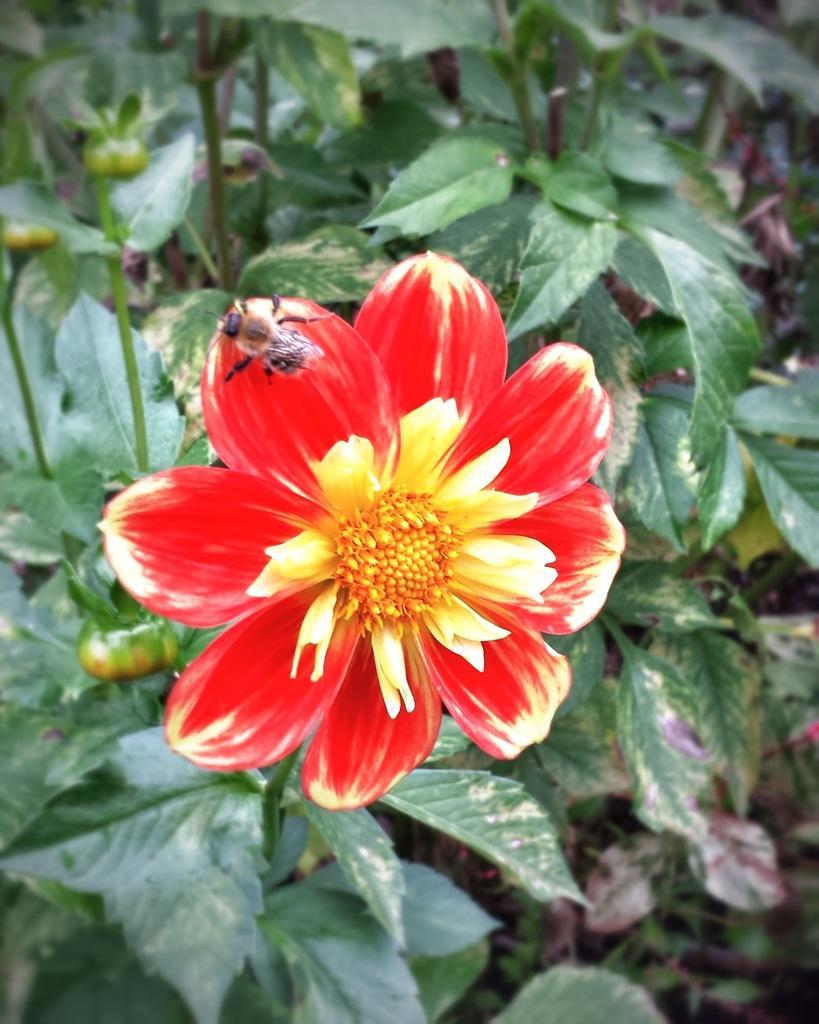How would you summarize this image in a sentence or two? In this image I can see the flower to the plant. The flower is in red and yellow color. And I can see the bee on the flower. 